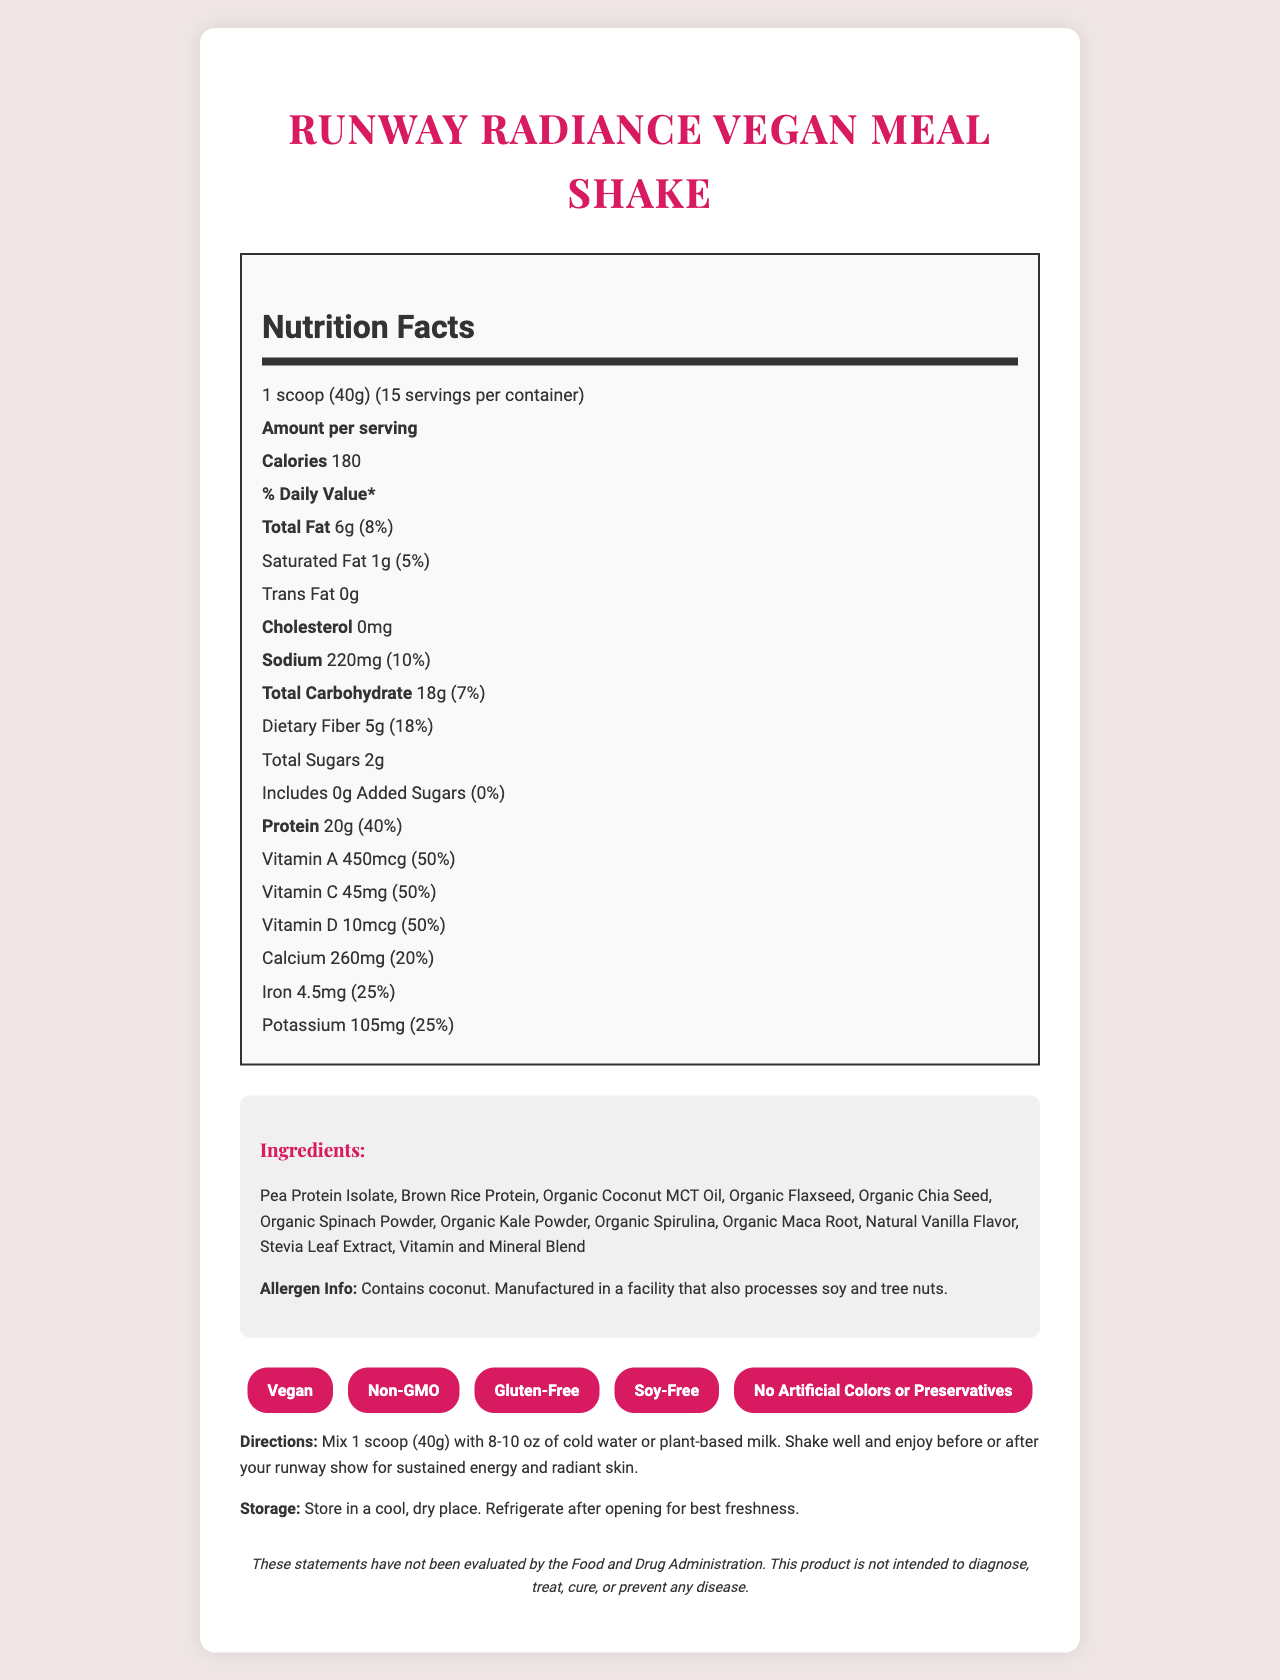what is the serving size? The document specifies that the serving size is "1 scoop (40g)".
Answer: 1 scoop (40g) how many servings are in a container? The document indicates that there are 15 servings per container.
Answer: 15 how many calories are in one serving? The nutrition label shows that there are 180 calories per serving.
Answer: 180 what is the amount of protein per serving? The document lists 20g of protein as the amount per serving.
Answer: 20g what is the total amount of sugars in one serving? According to the document, the total sugars per serving are 2g.
Answer: 2g what are the key features of the Runway Radiance Vegan Meal Shake? A. GMO B. Vegan C. Gluten-Free D. Contains Artificial Colors The document lists "Vegan" and "Gluten-Free" as key features, while no GMO or artificial colors are mentioned.
Answer: B, C how much sodium does each serving contain? A. 100mg B. 200mg C. 220mg D. 240mg The document specifies that each serving contains 220mg of sodium.
Answer: C is the Runway Radiance Vegan Meal Shake suitable for a soy-free diet? The document indicates that the product is soy-free.
Answer: Yes does this product contain any cholesterol? The nutrition label shows that the product contains 0mg of cholesterol.
Answer: No summarize the main idea of the document. The document includes various sections such as nutrition facts, ingredients, allergen info, special features, directions, storage instructions, and a disclaimer. Each section provides specific information about the product, ensuring consumers understand its benefits and use.
Answer: The document provides detailed nutrition facts, ingredients, and special features of the "Runway Radiance Vegan Meal Shake", emphasizing its vegan ingredients and suitability for maintaining energy and radiant skin for runway models. what is the purpose of the stevia leaf extract in the product? The document does not specify the purpose of each individual ingredient, including the stevia leaf extract.
Answer: Cannot be determined 